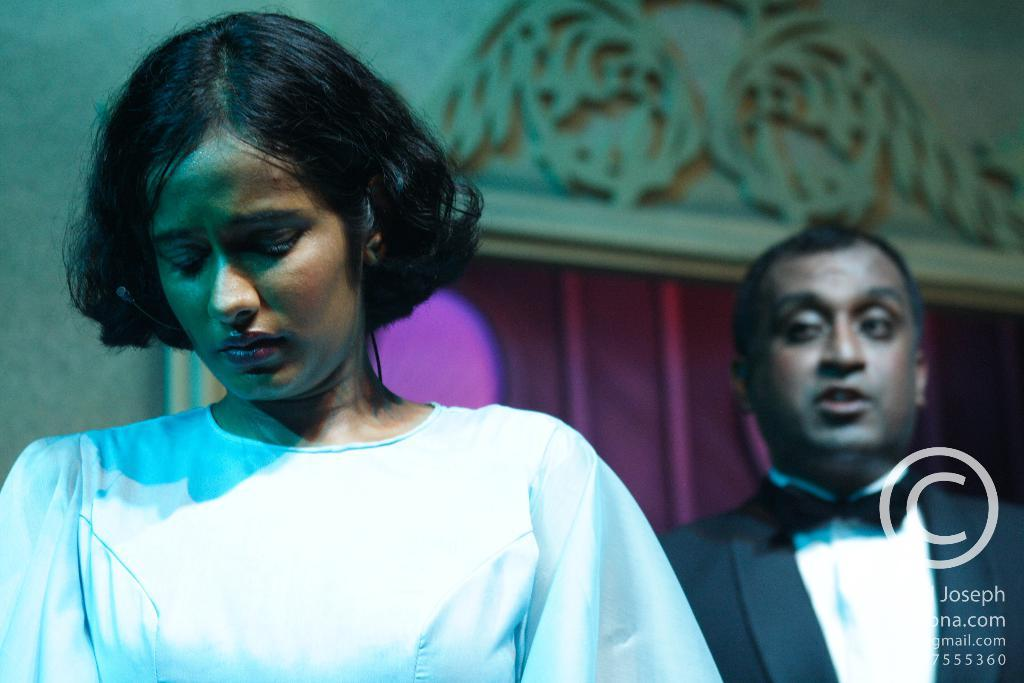How many people are in the image? There are two persons standing in the center of the image. What can be seen in the bottom right side of the image? There is a watermark in the bottom right side of the image. What is visible in the background of the image? There is a wall and a curtain in the background of the image. What type of comb is being used by the person on the left in the image? There is no comb visible in the image, and therefore no such activity can be observed. 